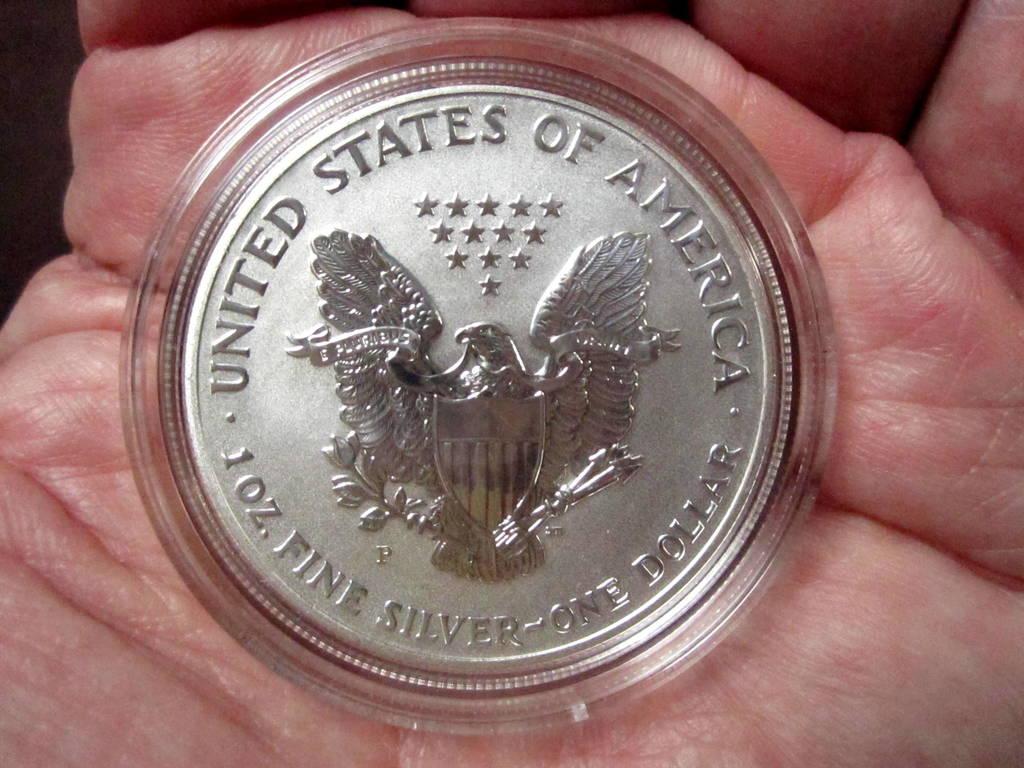What animal is on this coin?
Give a very brief answer. Answering does not require reading text in the image. 